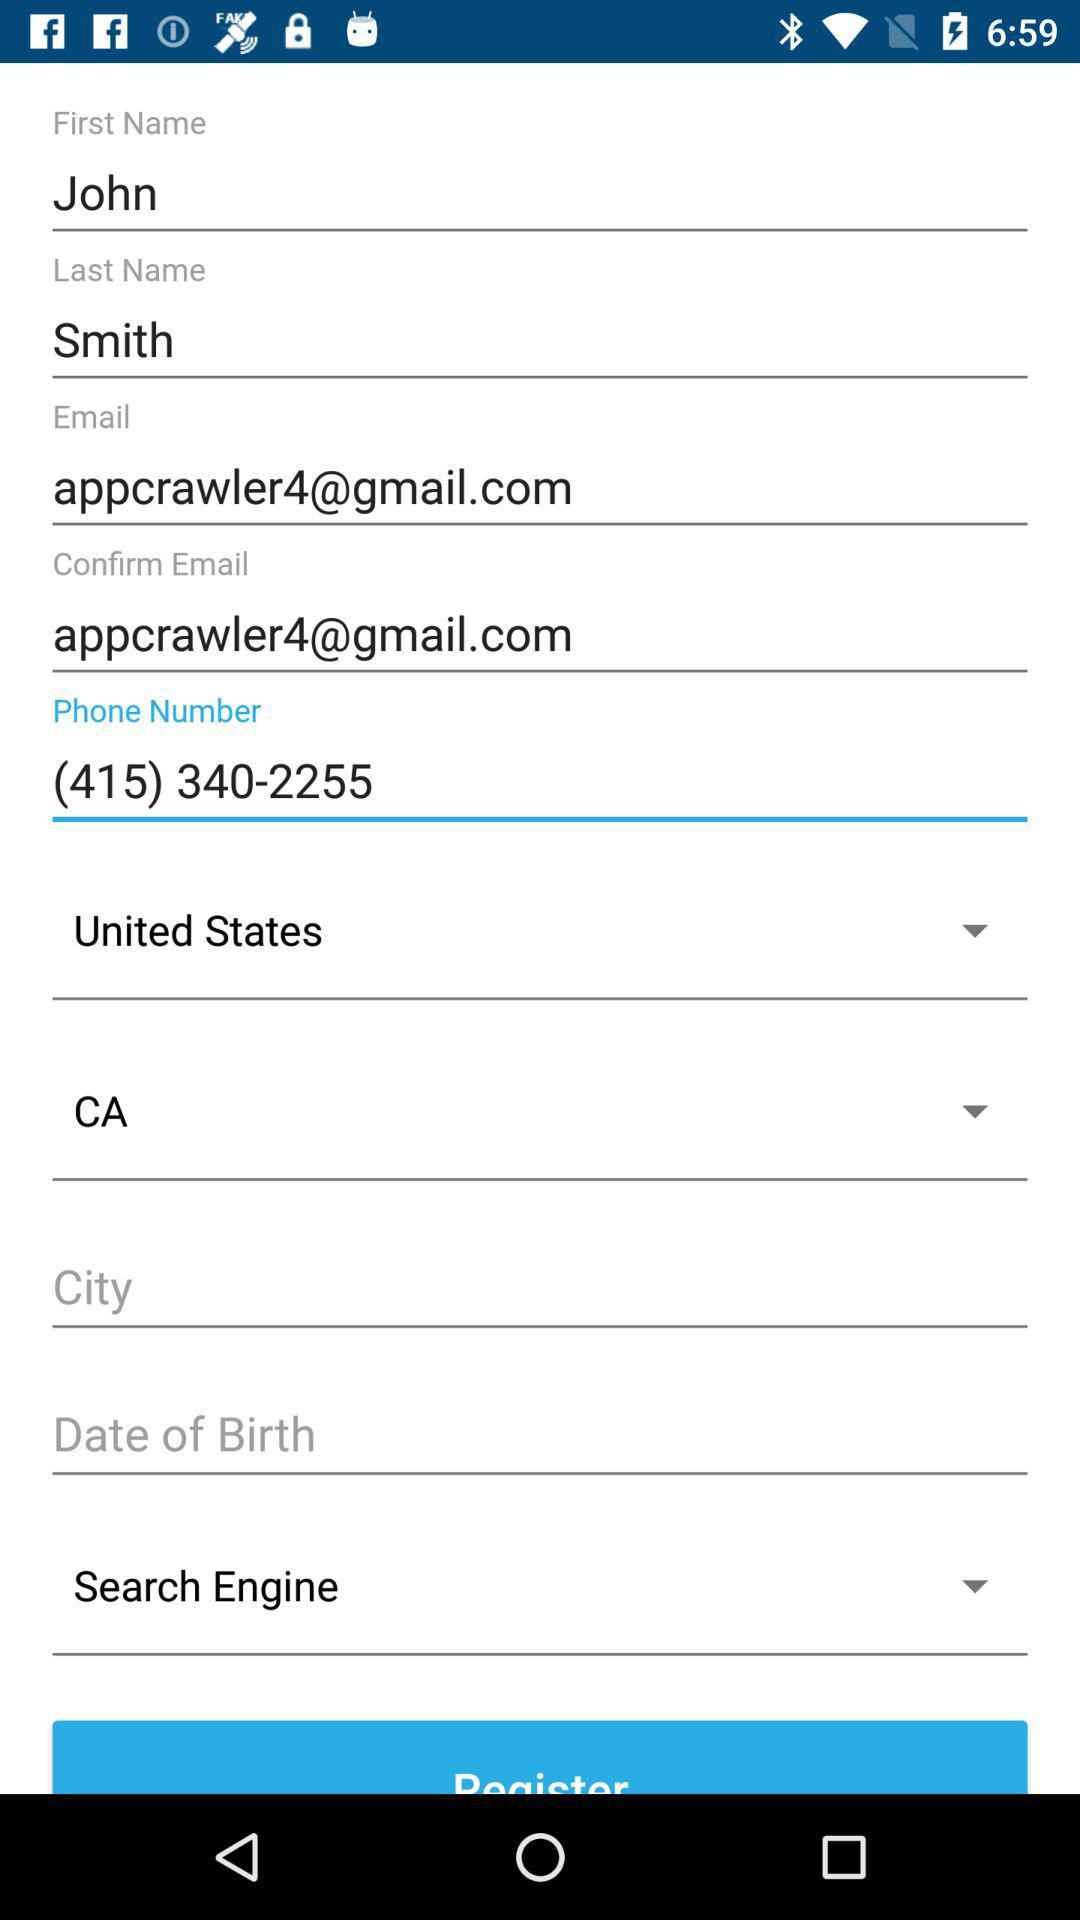What is the email address? The email address is appcrawler4@gmail.com. 